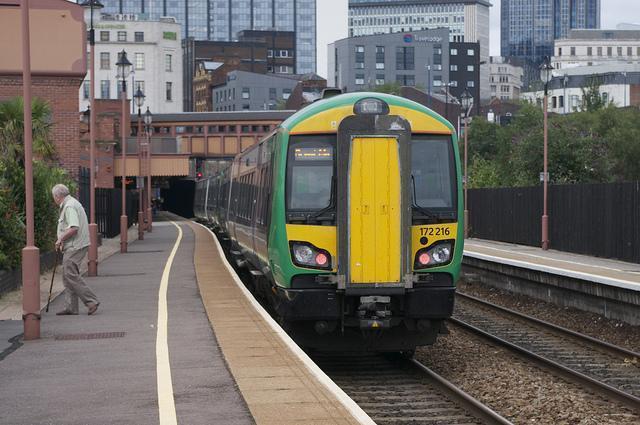How many people are standing on the train platform?
Give a very brief answer. 1. How many cups are on the bed?
Give a very brief answer. 0. 